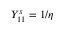Convert formula to latex. <formula><loc_0><loc_0><loc_500><loc_500>Y _ { 1 1 } ^ { s } = 1 / \eta</formula> 